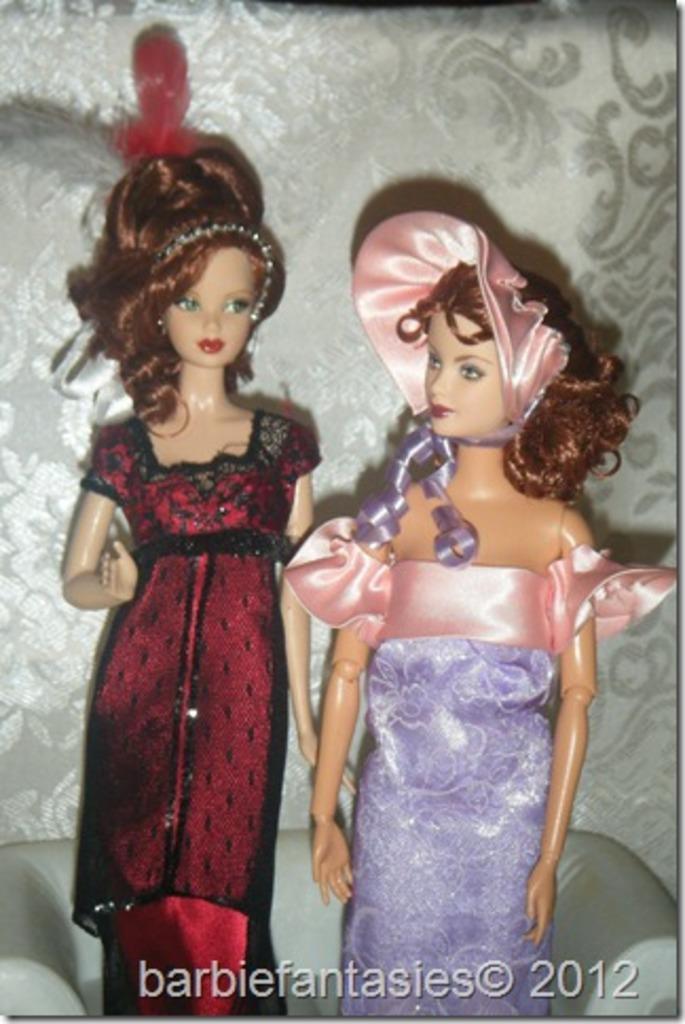Describe this image in one or two sentences. In this image in front there are two barbie dolls on the sofa. In the background of the image there is a wall and there is some text written at the bottom of the image. 